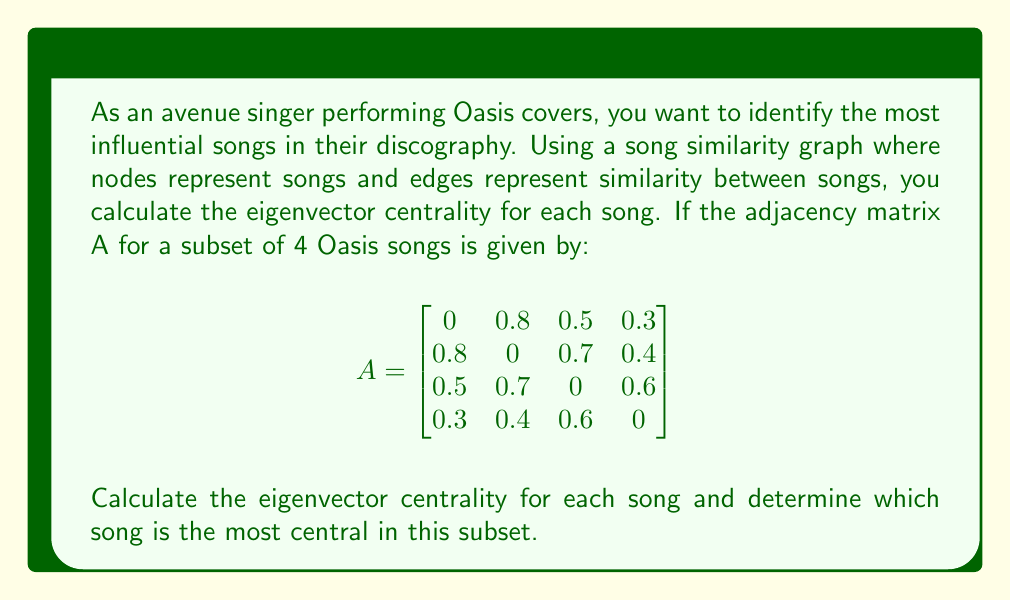Give your solution to this math problem. To solve this problem, we need to follow these steps:

1) First, we need to find the principal eigenvector of the adjacency matrix A. This eigenvector corresponds to the largest eigenvalue of A.

2) To find the eigenvalues, we solve the characteristic equation:
   $\det(A - \lambda I) = 0$

3) The largest eigenvalue (λ_max) is approximately 1.6180.

4) Now, we need to find the eigenvector x that satisfies:
   $Ax = \lambda_{max}x$

5) Solving this equation gives us the unnormalized eigenvector:
   $x \approx [0.8944, 1.0000, 0.9511, 0.6180]$

6) To get the eigenvector centrality, we normalize this vector so that the sum of squares equals 1:

   $$x_{normalized} = \frac{x}{\sqrt{\sum x_i^2}}$$

7) This gives us the eigenvector centrality for each song:
   
   Song 1: 0.5096
   Song 2: 0.5697
   Song 3: 0.5419
   Song 4: 0.3521

8) The song with the highest centrality score is the most central in the network.
Answer: Song 2 has the highest eigenvector centrality (0.5697), making it the most central song in this subset of the Oasis discography. 